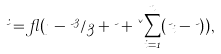Convert formula to latex. <formula><loc_0><loc_0><loc_500><loc_500>\dot { \psi } = \gamma ( \eta - \psi ^ { 3 } / 3 + \psi + \kappa \sum _ { i = 1 } ^ { n } ( \psi _ { i } - \psi ) ) ,</formula> 